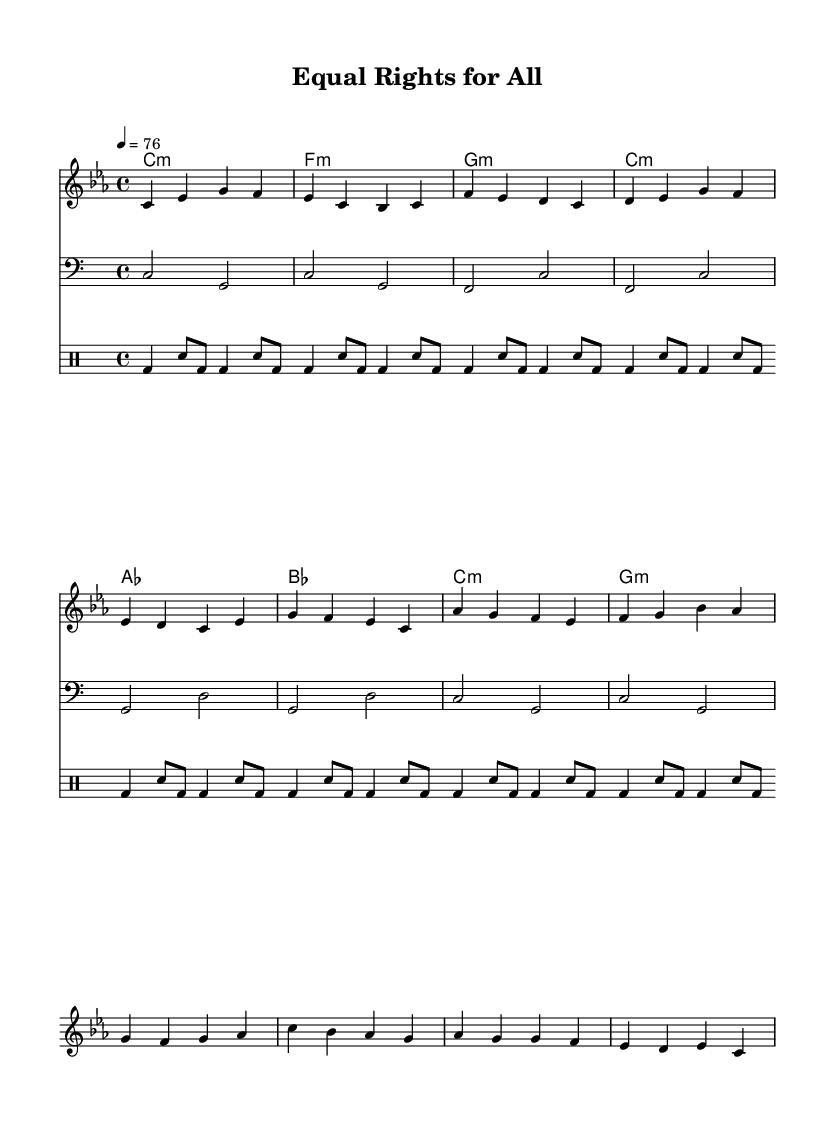What is the key signature of this music? The key signature is C minor, which has three flats (B♭, E♭, A♭). This is indicated at the beginning of the sheet music.
Answer: C minor What is the time signature of this music? The time signature is indicated as 4/4, which means there are four beats in each measure and the quarter note gets one beat. This is found at the beginning of the score.
Answer: 4/4 What is the tempo marking of this piece? The tempo marking is indicated as quarter note = 76, which means the piece should be played at a moderate speed with 76 beats per minute. This is shown near the start of the music.
Answer: 76 What is the first chord in the chord progression? The first chord is C minor, as indicated by the first symbol in the chord names section at the start of the piece.
Answer: C minor How many measures are in the verse section? The verse section consists of four measures, which can be counted from the melody line and the lyrics aligned with it. Each grouping of notes corresponds to a measure.
Answer: 4 What themes does the chorus address? The chorus addresses themes of equality and social justice, as expressed through the lyrics "Equal rights for all, that's our call / Stand up, speak out, break down every wall." This message is characteristic of roots reggae music.
Answer: Equality and social justice What rhythmic pattern is used in the drum part? The rhythmic pattern in the drum part features a repeating bass drum and snare rhythm, which is a common style in reggae music, creating a laid-back groove. This pattern is repeated throughout the drumming section.
Answer: Repeating bass and snare rhythm 